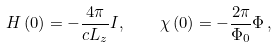<formula> <loc_0><loc_0><loc_500><loc_500>H \left ( 0 \right ) = - \frac { 4 \pi } { c L _ { z } } I , \quad \chi \left ( 0 \right ) = - \frac { 2 \pi } { \Phi _ { 0 } } \Phi \, ,</formula> 